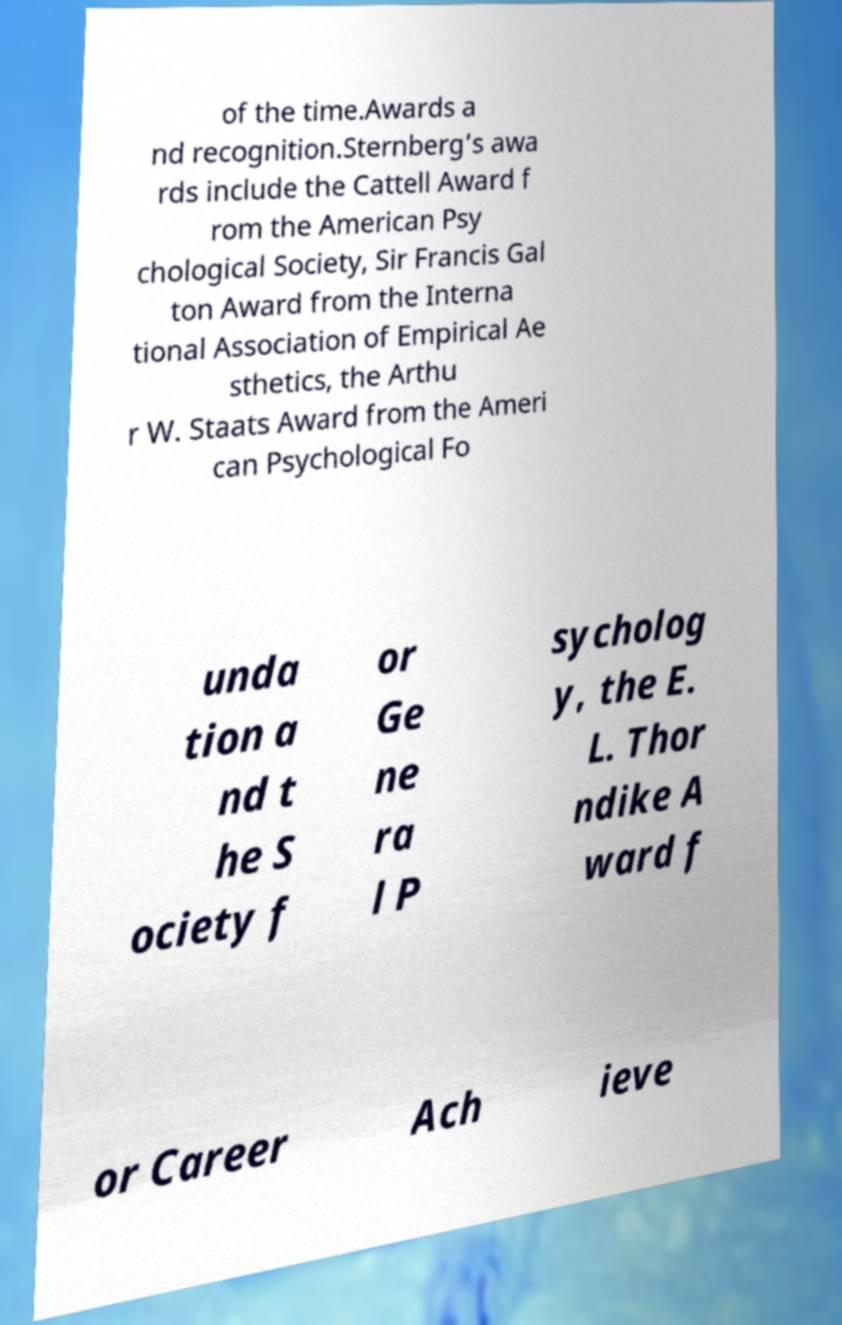Can you accurately transcribe the text from the provided image for me? of the time.Awards a nd recognition.Sternberg’s awa rds include the Cattell Award f rom the American Psy chological Society, Sir Francis Gal ton Award from the Interna tional Association of Empirical Ae sthetics, the Arthu r W. Staats Award from the Ameri can Psychological Fo unda tion a nd t he S ociety f or Ge ne ra l P sycholog y, the E. L. Thor ndike A ward f or Career Ach ieve 